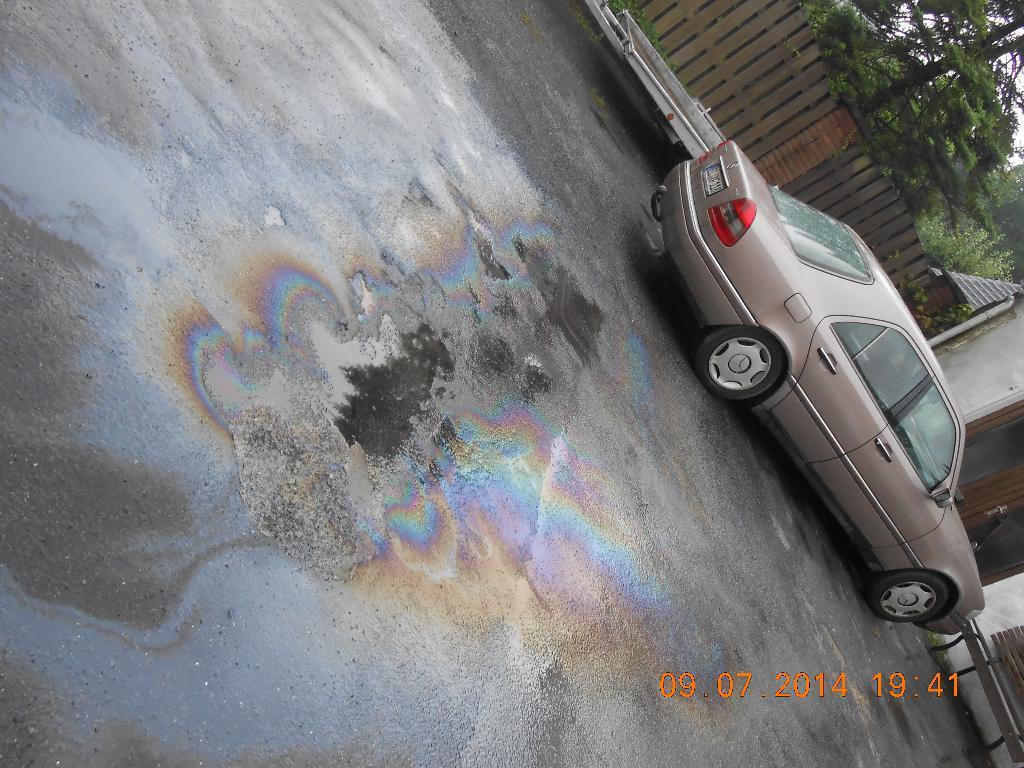Please provide a concise description of this image. In this image we can see a house at the right side of the image. There is a fence in the image. There are many trees in the image. There is a car in the image. We can see some water on the ground. 